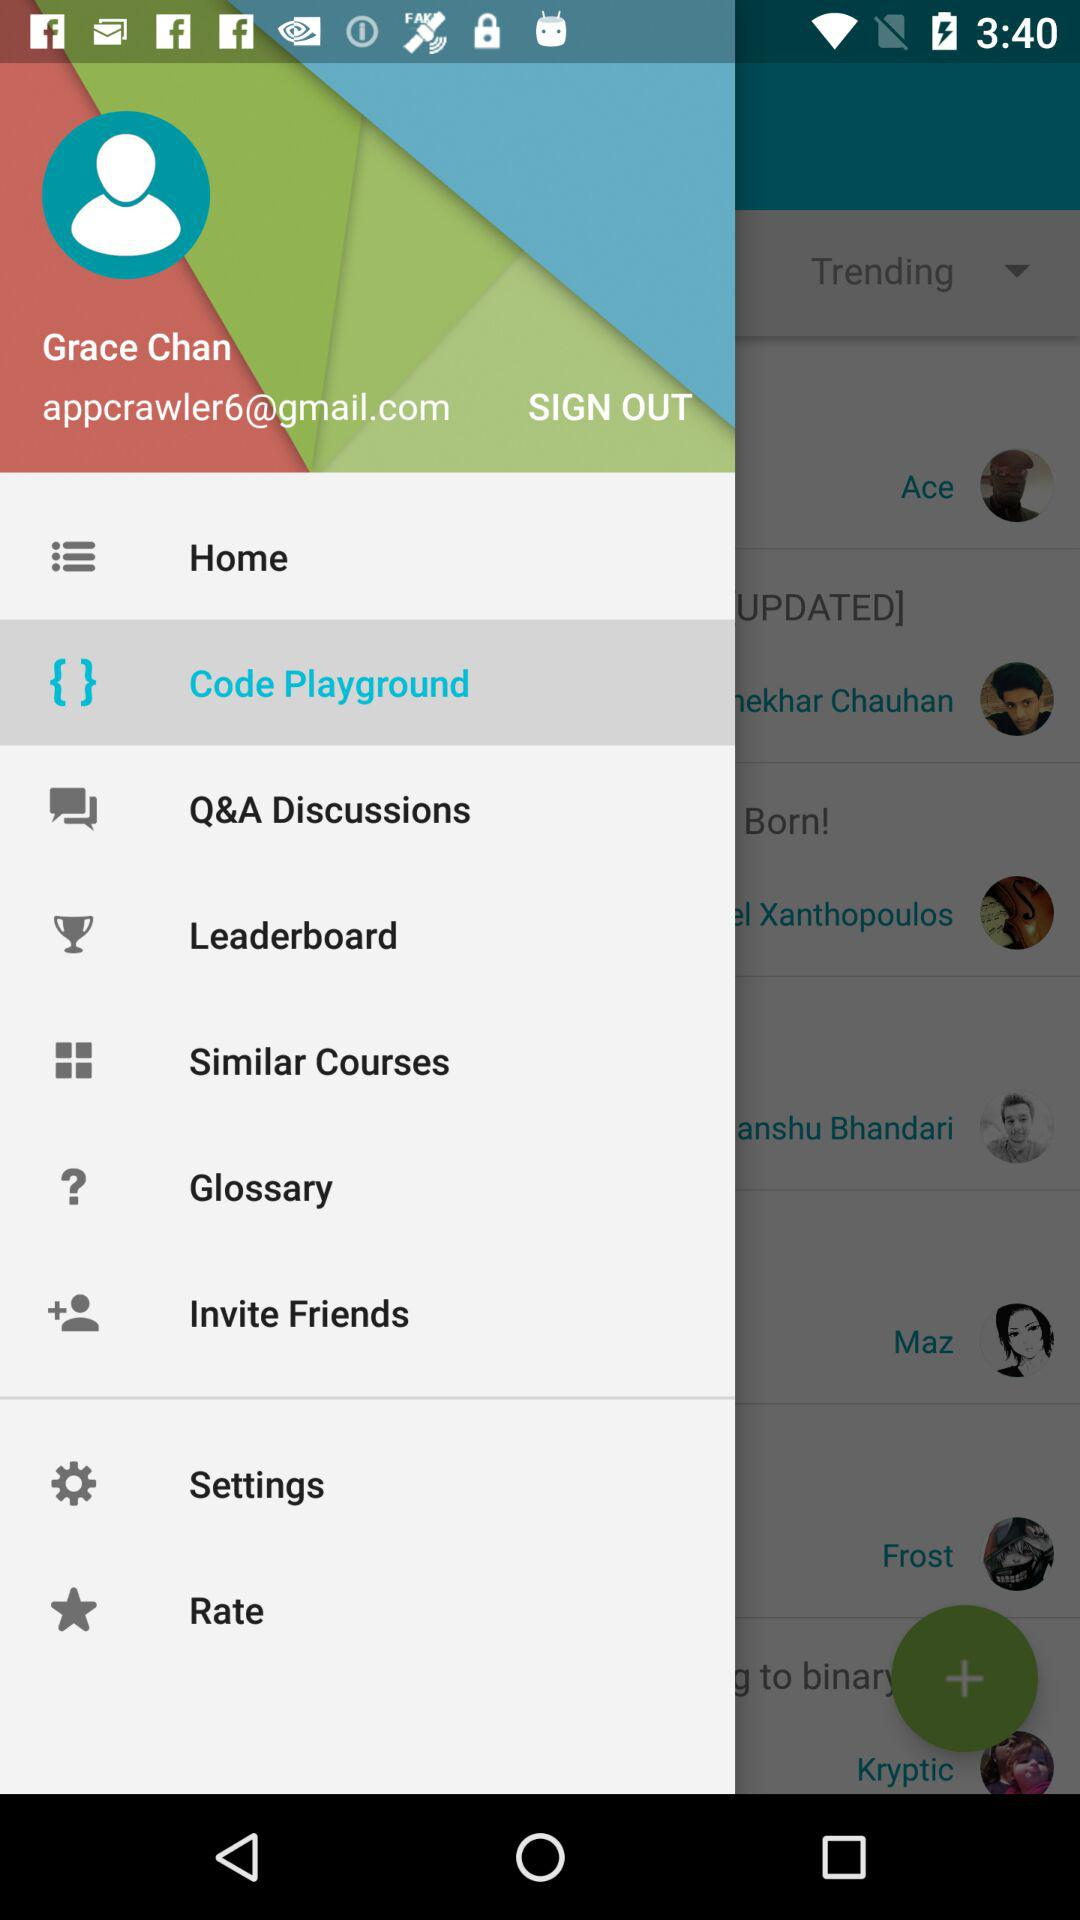What is the email address? The email address is appcrawler6@gmail.com. 